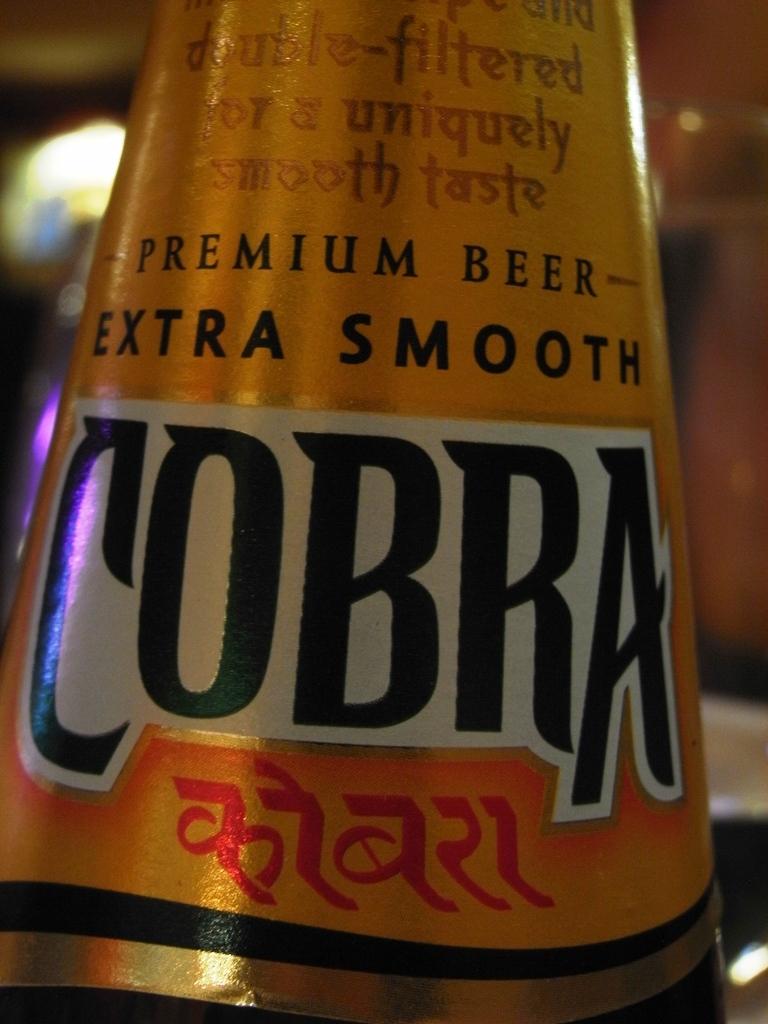What is the name of this beer?
Ensure brevity in your answer.  Cobra. 